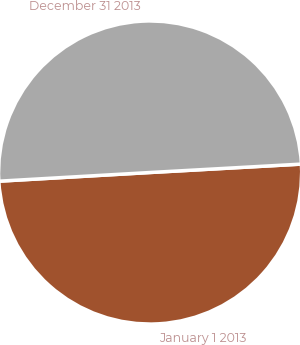<chart> <loc_0><loc_0><loc_500><loc_500><pie_chart><fcel>January 1 2013<fcel>December 31 2013<nl><fcel>49.97%<fcel>50.03%<nl></chart> 